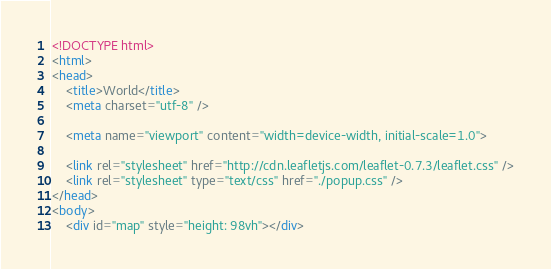Convert code to text. <code><loc_0><loc_0><loc_500><loc_500><_HTML_><!DOCTYPE html>
<html>
<head>
	<title>World</title>
	<meta charset="utf-8" />

	<meta name="viewport" content="width=device-width, initial-scale=1.0">

	<link rel="stylesheet" href="http://cdn.leafletjs.com/leaflet-0.7.3/leaflet.css" />
	<link rel="stylesheet" type="text/css" href="./popup.css" />
</head>
<body>
	<div id="map" style="height: 98vh"></div></code> 